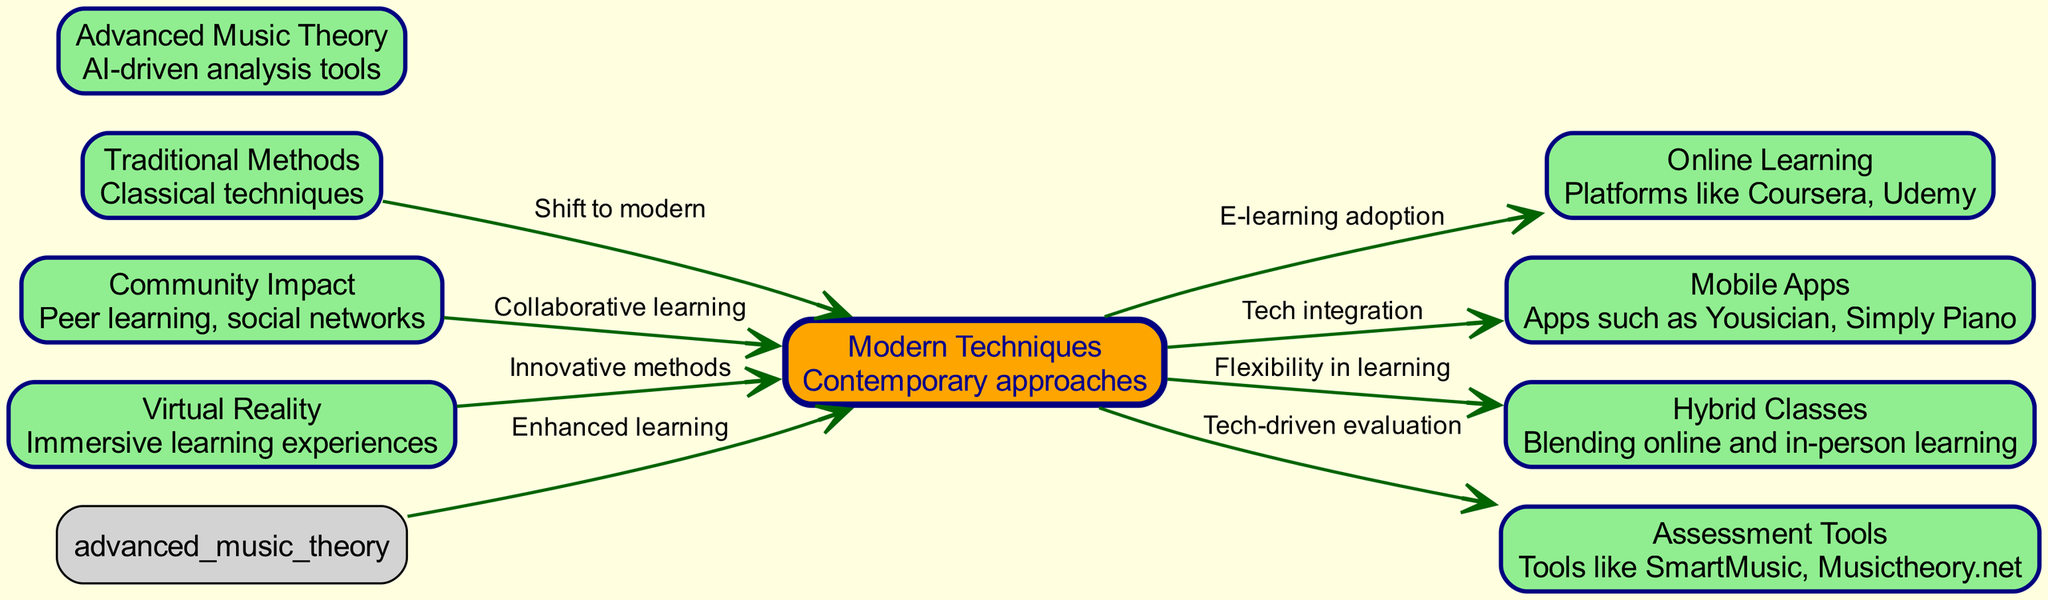What are the two main categories of teaching methods represented in the diagram? The diagram clearly separates teaching methods into two main categories: "Traditional Methods" and "Modern Techniques." Both are distinct nodes in the structure.
Answer: Traditional Methods, Modern Techniques How many nodes are displayed in the diagram? By counting all the nodes represented in the diagram, we see that there are a total of 9 nodes listed. Each node represents a unique concept in music education techniques.
Answer: 9 What does the arrow labeled "E-learning adoption" connect? The "E-learning adoption" arrow connects "Modern Techniques" to "Online Learning." This indicates a transition from modern teaching methods to incorporating online platforms.
Answer: Modern Techniques to Online Learning Which node is highlighted in orange? The node identified as "Modern Techniques" is highlighted in orange, indicating its significance within the diagram. It serves as a central hub for various modern approaches to music education.
Answer: Modern Techniques What relationship does "Community Impact" have with "Modern Techniques"? "Community Impact" is connected to "Modern Techniques" through an arrow that implies a relationship of "Collaborative learning." This suggests that modern techniques foster community engagement in music education.
Answer: Collaborative learning Which technique involves blending online and in-person learning? The technique that involves combining online learning with traditional classroom settings is referred to as "Hybrid Classes," represented as a node in the diagram.
Answer: Hybrid Classes What does the edge between "Advanced Music Theory" and "Modern Techniques" signify? The edge indicates that "Advanced Music Theory" enhances "Modern Techniques," suggesting that the incorporation of advanced theoretical knowledge improves contemporary learning methods.
Answer: Enhanced learning Which mobile applications are represented in the diagram? The diagram labels "Mobile Apps" specifically with examples like Yousician and Simply Piano, highlighting their role in modern music education techniques.
Answer: Yousician, Simply Piano What does the arrow labeled "Innovative methods" connect to? The arrow labeled "Innovative methods" connects "Virtual Reality" to "Modern Techniques," indicating that virtual reality is an innovative teaching method integrated into contemporary music education.
Answer: Virtual Reality to Modern Techniques 